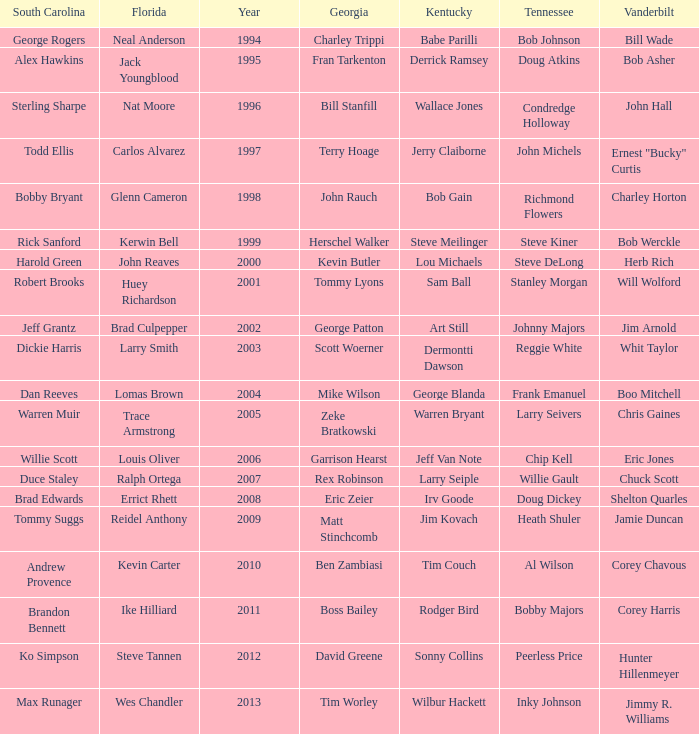What is the Tennessee that Georgia of kevin butler is in? Steve DeLong. 